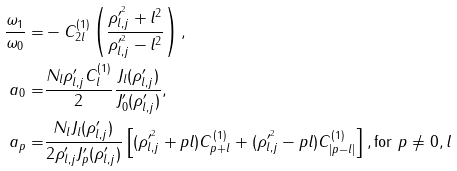Convert formula to latex. <formula><loc_0><loc_0><loc_500><loc_500>\frac { \omega _ { 1 } } { \omega _ { 0 } } = & - C _ { 2 l } ^ { ( 1 ) } \left ( \frac { \rho ^ { \prime ^ { 2 } } _ { l , j } + l ^ { 2 } } { \rho ^ { \prime ^ { 2 } } _ { l , j } - l ^ { 2 } } \right ) , \\ a _ { 0 } = & \frac { N _ { l } \rho ^ { \prime } _ { l , j } C _ { l } ^ { ( 1 ) } } { 2 } \frac { J _ { l } ( \rho ^ { \prime } _ { l , j } ) } { J _ { 0 } ^ { \prime } ( \rho ^ { \prime } _ { l , j } ) } , \\ a _ { p } = & \frac { N _ { l } J _ { l } ( \rho ^ { \prime } _ { l , j } ) } { 2 \rho ^ { \prime } _ { l , j } J _ { p } ^ { \prime } ( \rho ^ { \prime } _ { l , j } ) } \left [ ( \rho ^ { \prime ^ { 2 } } _ { l , j } + p l ) C _ { p + l } ^ { ( 1 ) } + ( \rho ^ { \prime ^ { 2 } } _ { l , j } - p l ) C _ { | p - l | } ^ { ( 1 ) } \right ] , \text {for $p\neq 0,l$}</formula> 